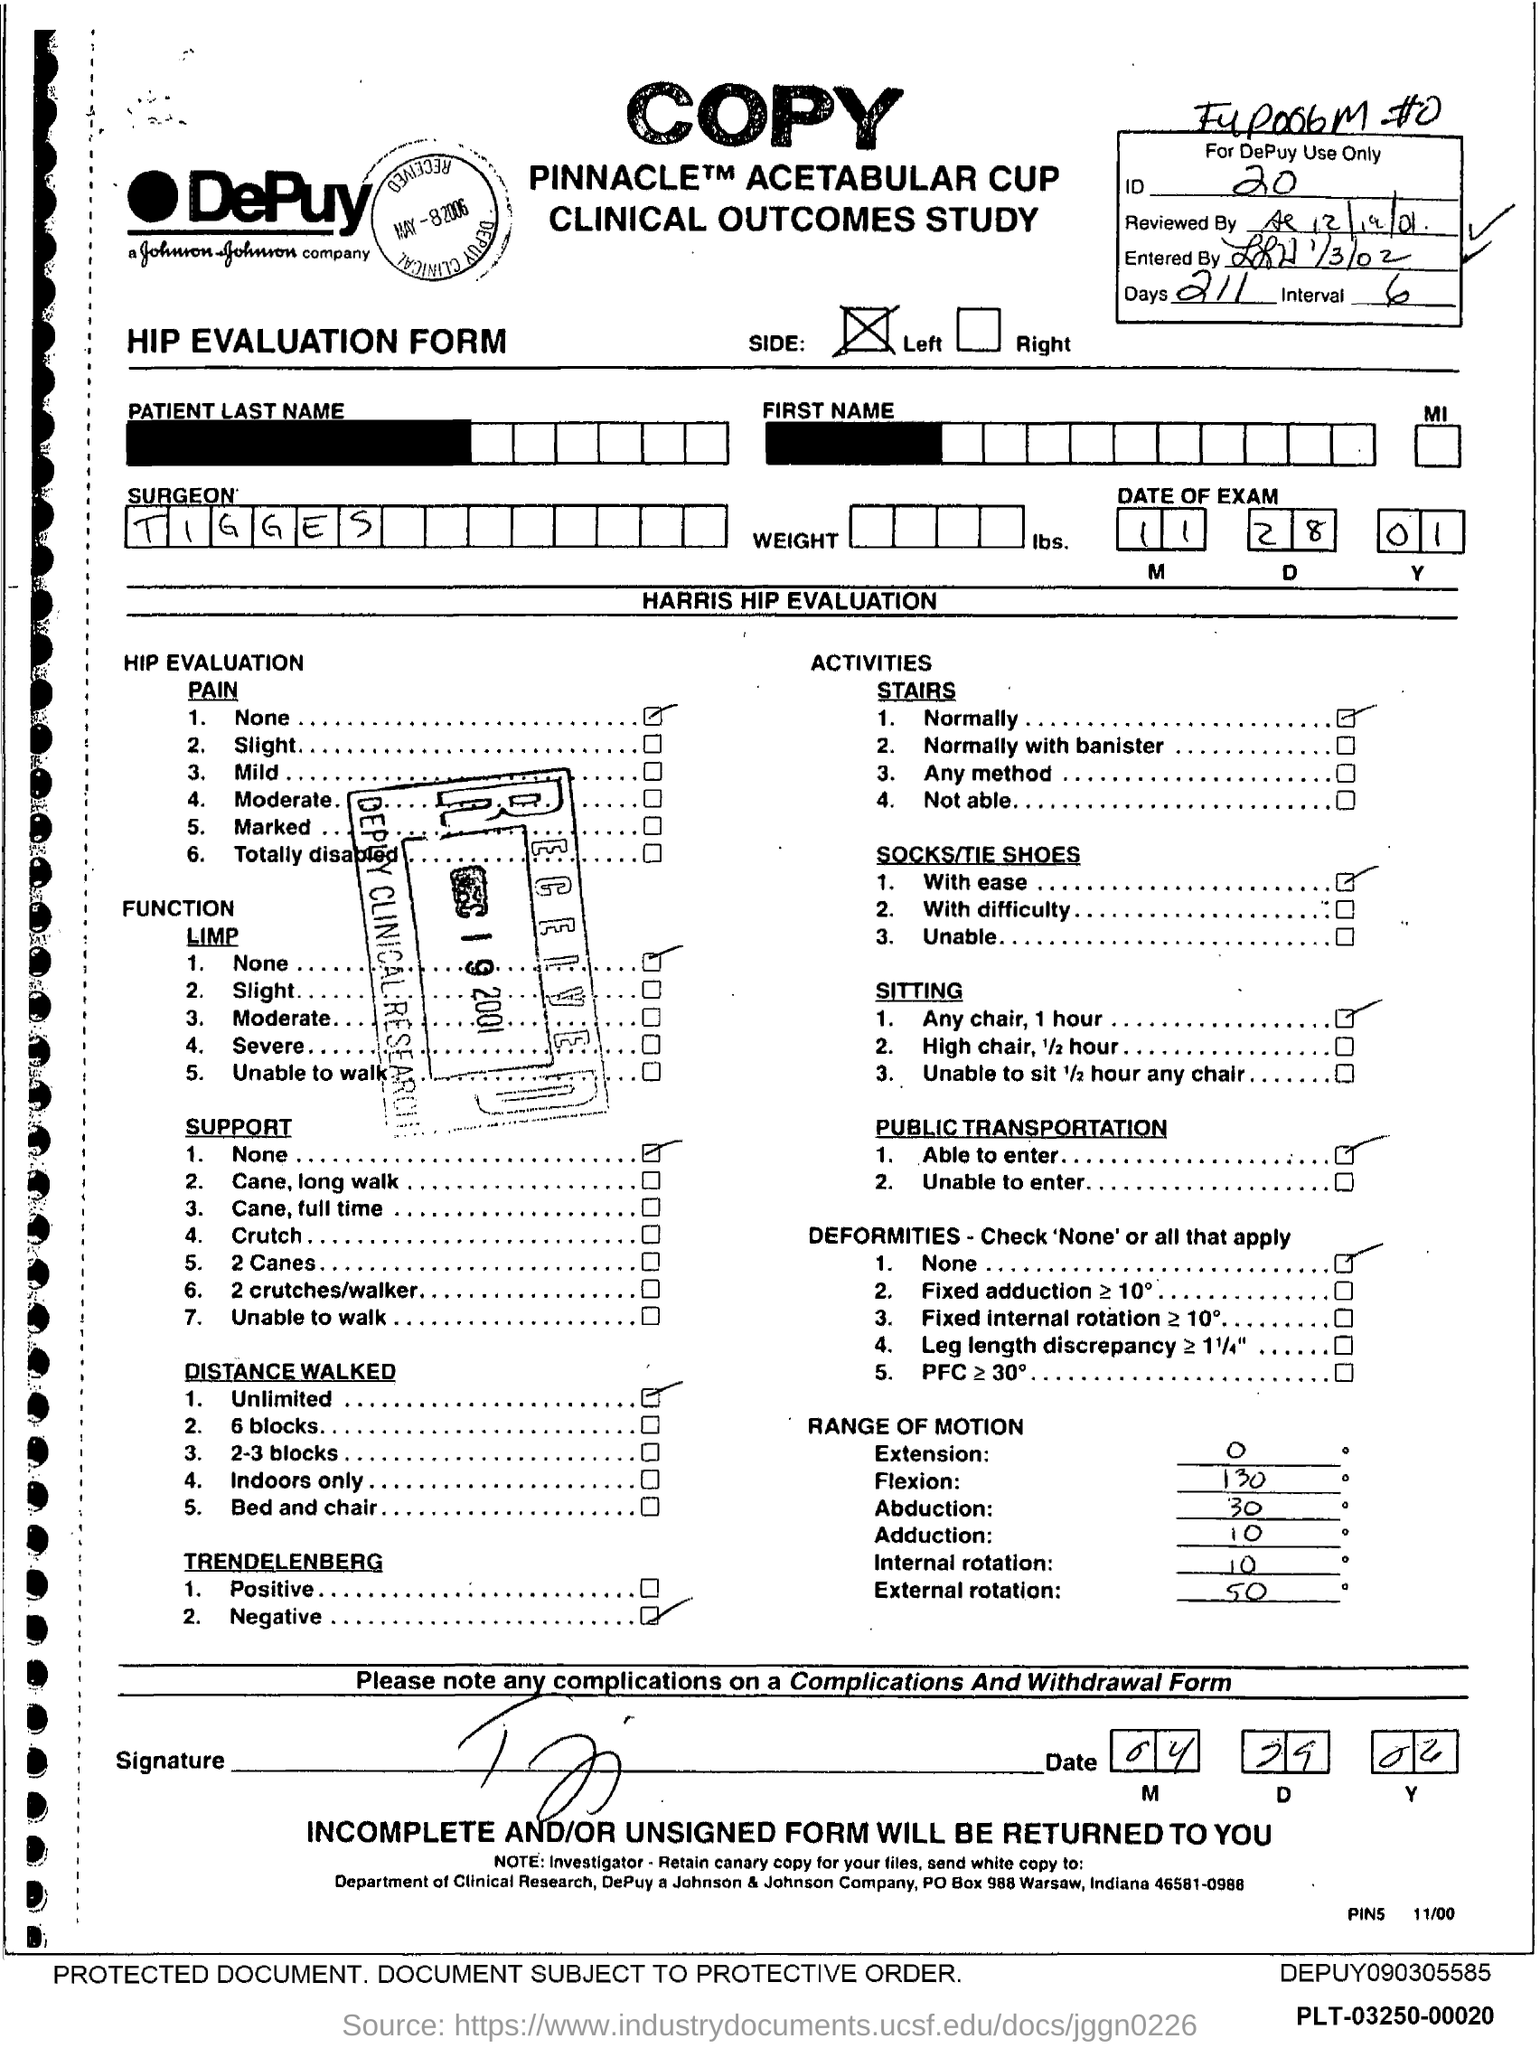Give some essential details in this illustration. The surgeon's name is Tigges. What is the ID Number? It is 20... The number of days is 211. 